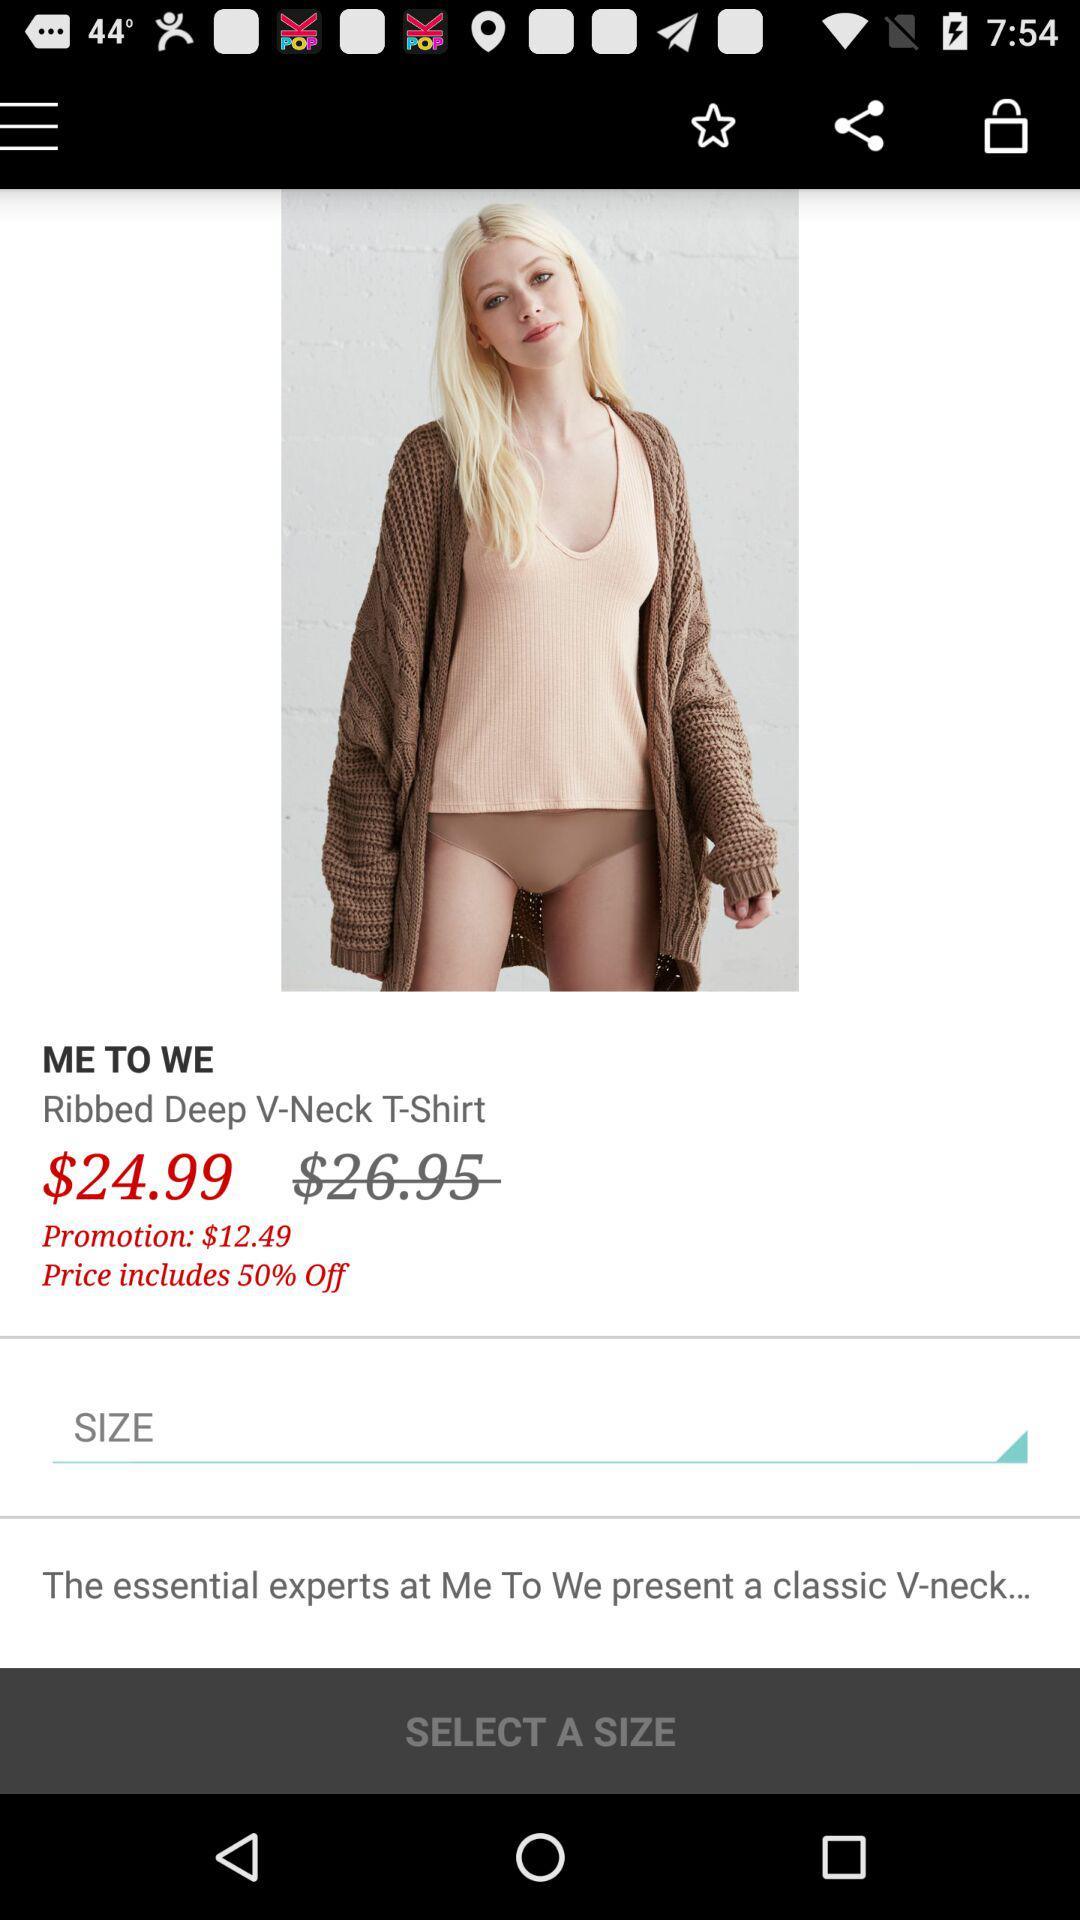How much is the original price of the item?
Answer the question using a single word or phrase. $26.95 